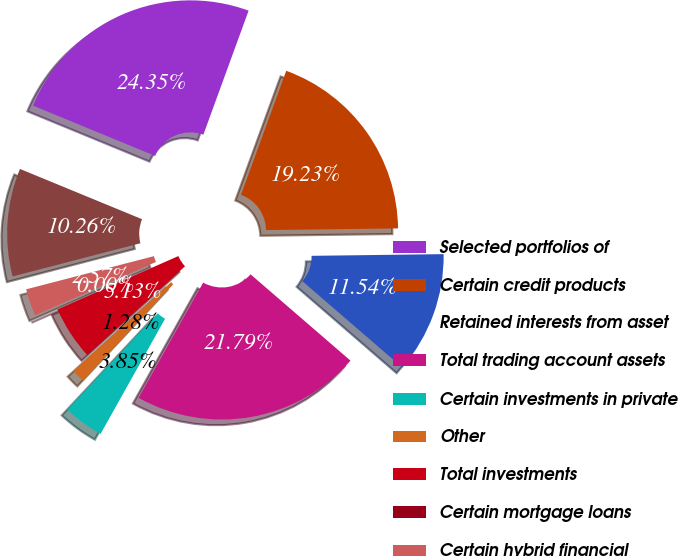Convert chart to OTSL. <chart><loc_0><loc_0><loc_500><loc_500><pie_chart><fcel>Selected portfolios of<fcel>Certain credit products<fcel>Retained interests from asset<fcel>Total trading account assets<fcel>Certain investments in private<fcel>Other<fcel>Total investments<fcel>Certain mortgage loans<fcel>Certain hybrid financial<fcel>Total loans<nl><fcel>24.35%<fcel>19.23%<fcel>11.54%<fcel>21.79%<fcel>3.85%<fcel>1.28%<fcel>5.13%<fcel>0.0%<fcel>2.57%<fcel>10.26%<nl></chart> 